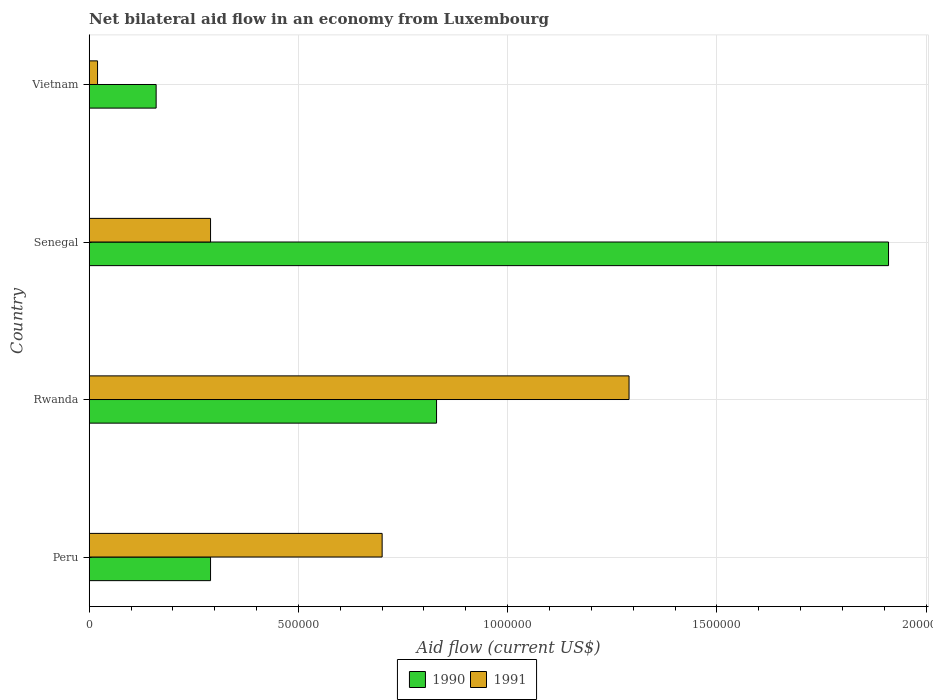How many different coloured bars are there?
Ensure brevity in your answer.  2. How many bars are there on the 1st tick from the top?
Ensure brevity in your answer.  2. What is the label of the 2nd group of bars from the top?
Your response must be concise. Senegal. In how many cases, is the number of bars for a given country not equal to the number of legend labels?
Offer a terse response. 0. What is the net bilateral aid flow in 1991 in Rwanda?
Make the answer very short. 1.29e+06. Across all countries, what is the maximum net bilateral aid flow in 1990?
Give a very brief answer. 1.91e+06. Across all countries, what is the minimum net bilateral aid flow in 1990?
Provide a succinct answer. 1.60e+05. In which country was the net bilateral aid flow in 1990 maximum?
Give a very brief answer. Senegal. In which country was the net bilateral aid flow in 1990 minimum?
Your answer should be very brief. Vietnam. What is the total net bilateral aid flow in 1991 in the graph?
Provide a succinct answer. 2.30e+06. What is the difference between the net bilateral aid flow in 1990 in Rwanda and that in Senegal?
Provide a short and direct response. -1.08e+06. What is the difference between the net bilateral aid flow in 1991 in Rwanda and the net bilateral aid flow in 1990 in Peru?
Offer a very short reply. 1.00e+06. What is the average net bilateral aid flow in 1991 per country?
Give a very brief answer. 5.75e+05. What is the ratio of the net bilateral aid flow in 1990 in Peru to that in Vietnam?
Provide a short and direct response. 1.81. What is the difference between the highest and the second highest net bilateral aid flow in 1991?
Make the answer very short. 5.90e+05. What is the difference between the highest and the lowest net bilateral aid flow in 1990?
Your answer should be very brief. 1.75e+06. How many bars are there?
Make the answer very short. 8. Are all the bars in the graph horizontal?
Give a very brief answer. Yes. How many countries are there in the graph?
Make the answer very short. 4. Are the values on the major ticks of X-axis written in scientific E-notation?
Your answer should be very brief. No. Does the graph contain any zero values?
Your answer should be compact. No. Does the graph contain grids?
Keep it short and to the point. Yes. Where does the legend appear in the graph?
Make the answer very short. Bottom center. How many legend labels are there?
Make the answer very short. 2. How are the legend labels stacked?
Ensure brevity in your answer.  Horizontal. What is the title of the graph?
Offer a very short reply. Net bilateral aid flow in an economy from Luxembourg. Does "2001" appear as one of the legend labels in the graph?
Give a very brief answer. No. What is the label or title of the Y-axis?
Offer a terse response. Country. What is the Aid flow (current US$) in 1991 in Peru?
Your answer should be compact. 7.00e+05. What is the Aid flow (current US$) in 1990 in Rwanda?
Provide a short and direct response. 8.30e+05. What is the Aid flow (current US$) of 1991 in Rwanda?
Keep it short and to the point. 1.29e+06. What is the Aid flow (current US$) of 1990 in Senegal?
Your answer should be very brief. 1.91e+06. What is the Aid flow (current US$) in 1991 in Senegal?
Offer a very short reply. 2.90e+05. What is the Aid flow (current US$) in 1990 in Vietnam?
Keep it short and to the point. 1.60e+05. Across all countries, what is the maximum Aid flow (current US$) of 1990?
Your answer should be compact. 1.91e+06. Across all countries, what is the maximum Aid flow (current US$) in 1991?
Give a very brief answer. 1.29e+06. Across all countries, what is the minimum Aid flow (current US$) in 1991?
Keep it short and to the point. 2.00e+04. What is the total Aid flow (current US$) of 1990 in the graph?
Your response must be concise. 3.19e+06. What is the total Aid flow (current US$) in 1991 in the graph?
Your answer should be very brief. 2.30e+06. What is the difference between the Aid flow (current US$) in 1990 in Peru and that in Rwanda?
Offer a very short reply. -5.40e+05. What is the difference between the Aid flow (current US$) of 1991 in Peru and that in Rwanda?
Offer a very short reply. -5.90e+05. What is the difference between the Aid flow (current US$) of 1990 in Peru and that in Senegal?
Offer a terse response. -1.62e+06. What is the difference between the Aid flow (current US$) of 1991 in Peru and that in Vietnam?
Your response must be concise. 6.80e+05. What is the difference between the Aid flow (current US$) in 1990 in Rwanda and that in Senegal?
Ensure brevity in your answer.  -1.08e+06. What is the difference between the Aid flow (current US$) of 1990 in Rwanda and that in Vietnam?
Keep it short and to the point. 6.70e+05. What is the difference between the Aid flow (current US$) in 1991 in Rwanda and that in Vietnam?
Your answer should be very brief. 1.27e+06. What is the difference between the Aid flow (current US$) in 1990 in Senegal and that in Vietnam?
Ensure brevity in your answer.  1.75e+06. What is the difference between the Aid flow (current US$) in 1990 in Rwanda and the Aid flow (current US$) in 1991 in Senegal?
Offer a very short reply. 5.40e+05. What is the difference between the Aid flow (current US$) in 1990 in Rwanda and the Aid flow (current US$) in 1991 in Vietnam?
Your response must be concise. 8.10e+05. What is the difference between the Aid flow (current US$) in 1990 in Senegal and the Aid flow (current US$) in 1991 in Vietnam?
Your answer should be very brief. 1.89e+06. What is the average Aid flow (current US$) of 1990 per country?
Your answer should be very brief. 7.98e+05. What is the average Aid flow (current US$) of 1991 per country?
Ensure brevity in your answer.  5.75e+05. What is the difference between the Aid flow (current US$) in 1990 and Aid flow (current US$) in 1991 in Peru?
Give a very brief answer. -4.10e+05. What is the difference between the Aid flow (current US$) in 1990 and Aid flow (current US$) in 1991 in Rwanda?
Make the answer very short. -4.60e+05. What is the difference between the Aid flow (current US$) of 1990 and Aid flow (current US$) of 1991 in Senegal?
Offer a terse response. 1.62e+06. What is the difference between the Aid flow (current US$) in 1990 and Aid flow (current US$) in 1991 in Vietnam?
Provide a short and direct response. 1.40e+05. What is the ratio of the Aid flow (current US$) of 1990 in Peru to that in Rwanda?
Provide a short and direct response. 0.35. What is the ratio of the Aid flow (current US$) of 1991 in Peru to that in Rwanda?
Your answer should be very brief. 0.54. What is the ratio of the Aid flow (current US$) of 1990 in Peru to that in Senegal?
Provide a succinct answer. 0.15. What is the ratio of the Aid flow (current US$) of 1991 in Peru to that in Senegal?
Offer a very short reply. 2.41. What is the ratio of the Aid flow (current US$) of 1990 in Peru to that in Vietnam?
Offer a terse response. 1.81. What is the ratio of the Aid flow (current US$) in 1990 in Rwanda to that in Senegal?
Provide a succinct answer. 0.43. What is the ratio of the Aid flow (current US$) in 1991 in Rwanda to that in Senegal?
Provide a short and direct response. 4.45. What is the ratio of the Aid flow (current US$) of 1990 in Rwanda to that in Vietnam?
Give a very brief answer. 5.19. What is the ratio of the Aid flow (current US$) of 1991 in Rwanda to that in Vietnam?
Your answer should be compact. 64.5. What is the ratio of the Aid flow (current US$) of 1990 in Senegal to that in Vietnam?
Keep it short and to the point. 11.94. What is the difference between the highest and the second highest Aid flow (current US$) in 1990?
Keep it short and to the point. 1.08e+06. What is the difference between the highest and the second highest Aid flow (current US$) in 1991?
Your response must be concise. 5.90e+05. What is the difference between the highest and the lowest Aid flow (current US$) in 1990?
Offer a very short reply. 1.75e+06. What is the difference between the highest and the lowest Aid flow (current US$) of 1991?
Ensure brevity in your answer.  1.27e+06. 